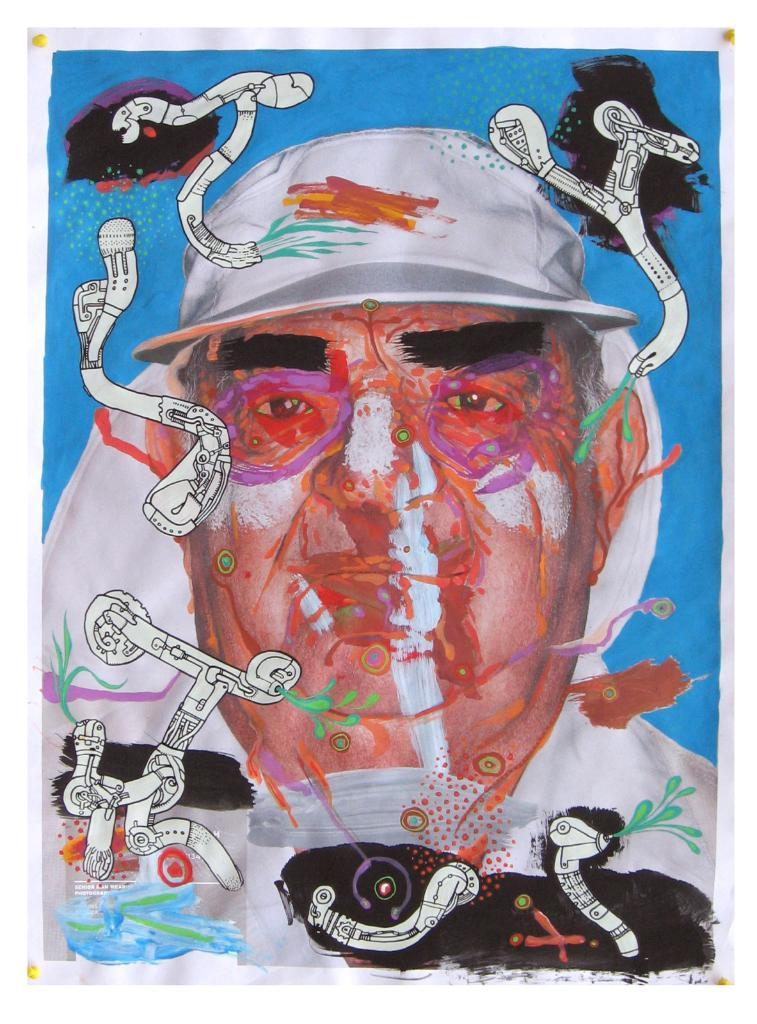What is the main subject of the image? There is a depiction of a man in the image. What color can be seen on some objects in the image? There are white color things in the image. What color is the background of the image? The background of the image is blue. Can you tell me how many swings are present in the image? There is no swing present in the image; it features a depiction of a man with a blue background and white objects. What type of support is the man using in the image? The image does not show the man using any specific support; it only depicts him without any context of his surroundings or actions. 